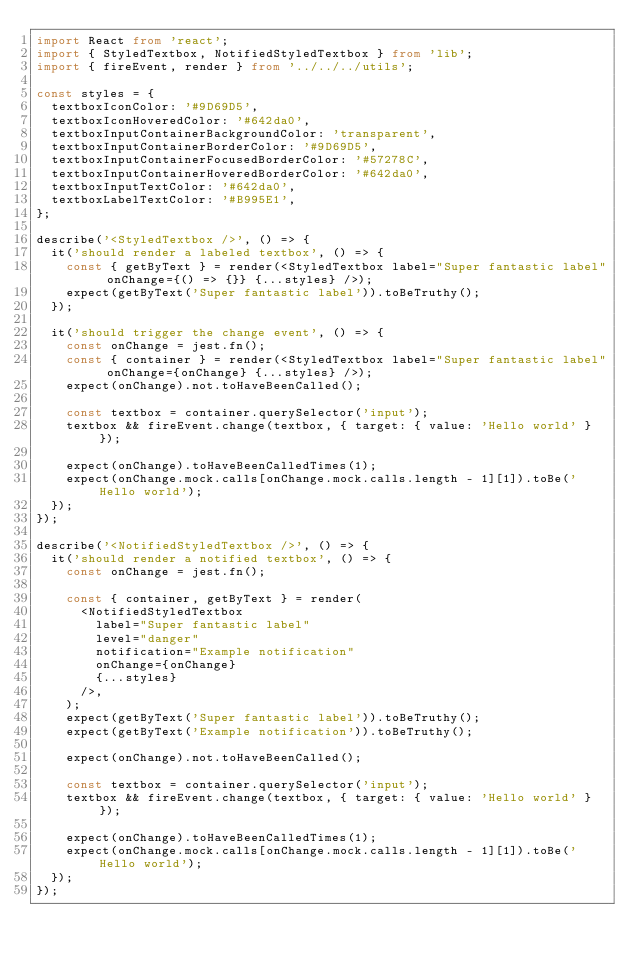<code> <loc_0><loc_0><loc_500><loc_500><_TypeScript_>import React from 'react';
import { StyledTextbox, NotifiedStyledTextbox } from 'lib';
import { fireEvent, render } from '../../../utils';

const styles = {
  textboxIconColor: '#9D69D5',
  textboxIconHoveredColor: '#642da0',
  textboxInputContainerBackgroundColor: 'transparent',
  textboxInputContainerBorderColor: '#9D69D5',
  textboxInputContainerFocusedBorderColor: '#57278C',
  textboxInputContainerHoveredBorderColor: '#642da0',
  textboxInputTextColor: '#642da0',
  textboxLabelTextColor: '#B995E1',
};

describe('<StyledTextbox />', () => {
  it('should render a labeled textbox', () => {
    const { getByText } = render(<StyledTextbox label="Super fantastic label" onChange={() => {}} {...styles} />);
    expect(getByText('Super fantastic label')).toBeTruthy();
  });

  it('should trigger the change event', () => {
    const onChange = jest.fn();
    const { container } = render(<StyledTextbox label="Super fantastic label" onChange={onChange} {...styles} />);
    expect(onChange).not.toHaveBeenCalled();

    const textbox = container.querySelector('input');
    textbox && fireEvent.change(textbox, { target: { value: 'Hello world' } });

    expect(onChange).toHaveBeenCalledTimes(1);
    expect(onChange.mock.calls[onChange.mock.calls.length - 1][1]).toBe('Hello world');
  });
});

describe('<NotifiedStyledTextbox />', () => {
  it('should render a notified textbox', () => {
    const onChange = jest.fn();

    const { container, getByText } = render(
      <NotifiedStyledTextbox
        label="Super fantastic label"
        level="danger"
        notification="Example notification"
        onChange={onChange}
        {...styles}
      />,
    );
    expect(getByText('Super fantastic label')).toBeTruthy();
    expect(getByText('Example notification')).toBeTruthy();

    expect(onChange).not.toHaveBeenCalled();

    const textbox = container.querySelector('input');
    textbox && fireEvent.change(textbox, { target: { value: 'Hello world' } });

    expect(onChange).toHaveBeenCalledTimes(1);
    expect(onChange.mock.calls[onChange.mock.calls.length - 1][1]).toBe('Hello world');
  });
});
</code> 